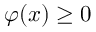Convert formula to latex. <formula><loc_0><loc_0><loc_500><loc_500>\varphi ( { x } ) \geq 0</formula> 